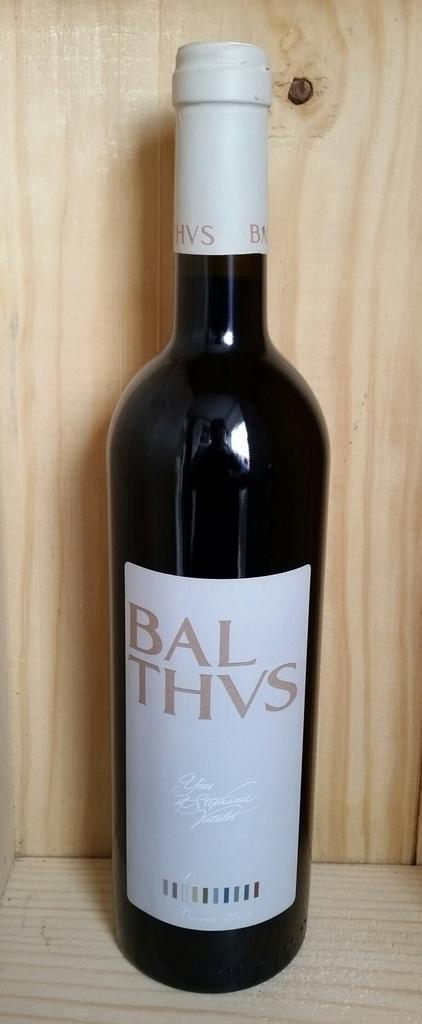<image>
Create a compact narrative representing the image presented. A bottle is labelled Bal Thvs and has a white label. 